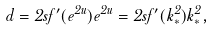Convert formula to latex. <formula><loc_0><loc_0><loc_500><loc_500>d = 2 s f ^ { \prime } ( e ^ { 2 u } ) e ^ { 2 u } = 2 s f ^ { \prime } ( k _ { * } ^ { 2 } ) k _ { * } ^ { 2 } ,</formula> 